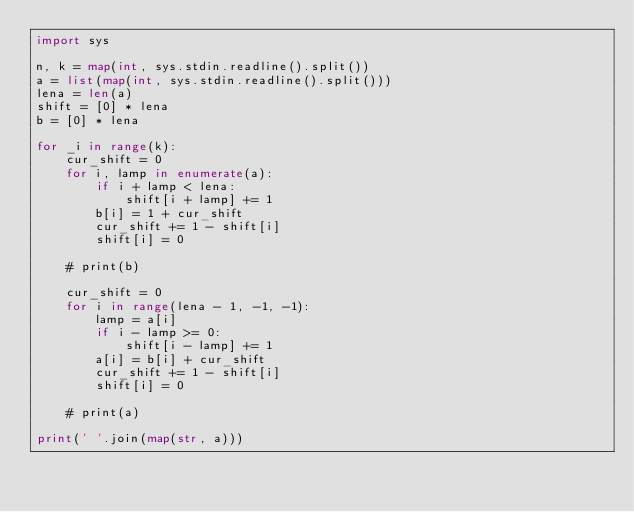Convert code to text. <code><loc_0><loc_0><loc_500><loc_500><_Python_>import sys

n, k = map(int, sys.stdin.readline().split())
a = list(map(int, sys.stdin.readline().split()))
lena = len(a)
shift = [0] * lena
b = [0] * lena

for _i in range(k):
    cur_shift = 0
    for i, lamp in enumerate(a):
        if i + lamp < lena:
            shift[i + lamp] += 1
        b[i] = 1 + cur_shift
        cur_shift += 1 - shift[i]
        shift[i] = 0

    # print(b)

    cur_shift = 0
    for i in range(lena - 1, -1, -1):
        lamp = a[i]
        if i - lamp >= 0:
            shift[i - lamp] += 1
        a[i] = b[i] + cur_shift
        cur_shift += 1 - shift[i]
        shift[i] = 0

    # print(a)

print(' '.join(map(str, a)))
</code> 